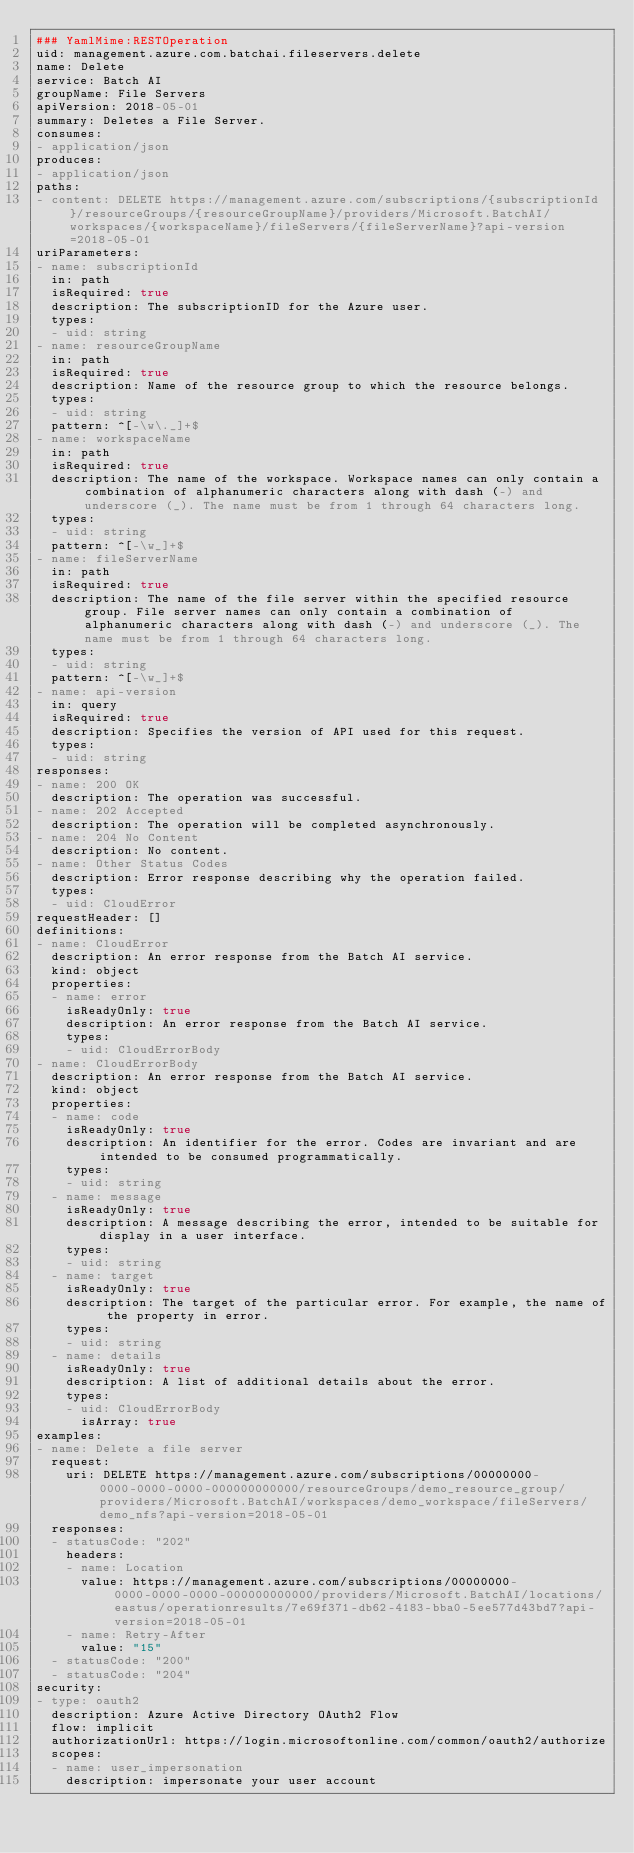<code> <loc_0><loc_0><loc_500><loc_500><_YAML_>### YamlMime:RESTOperation
uid: management.azure.com.batchai.fileservers.delete
name: Delete
service: Batch AI
groupName: File Servers
apiVersion: 2018-05-01
summary: Deletes a File Server.
consumes:
- application/json
produces:
- application/json
paths:
- content: DELETE https://management.azure.com/subscriptions/{subscriptionId}/resourceGroups/{resourceGroupName}/providers/Microsoft.BatchAI/workspaces/{workspaceName}/fileServers/{fileServerName}?api-version=2018-05-01
uriParameters:
- name: subscriptionId
  in: path
  isRequired: true
  description: The subscriptionID for the Azure user.
  types:
  - uid: string
- name: resourceGroupName
  in: path
  isRequired: true
  description: Name of the resource group to which the resource belongs.
  types:
  - uid: string
  pattern: ^[-\w\._]+$
- name: workspaceName
  in: path
  isRequired: true
  description: The name of the workspace. Workspace names can only contain a combination of alphanumeric characters along with dash (-) and underscore (_). The name must be from 1 through 64 characters long.
  types:
  - uid: string
  pattern: ^[-\w_]+$
- name: fileServerName
  in: path
  isRequired: true
  description: The name of the file server within the specified resource group. File server names can only contain a combination of alphanumeric characters along with dash (-) and underscore (_). The name must be from 1 through 64 characters long.
  types:
  - uid: string
  pattern: ^[-\w_]+$
- name: api-version
  in: query
  isRequired: true
  description: Specifies the version of API used for this request.
  types:
  - uid: string
responses:
- name: 200 OK
  description: The operation was successful.
- name: 202 Accepted
  description: The operation will be completed asynchronously.
- name: 204 No Content
  description: No content.
- name: Other Status Codes
  description: Error response describing why the operation failed.
  types:
  - uid: CloudError
requestHeader: []
definitions:
- name: CloudError
  description: An error response from the Batch AI service.
  kind: object
  properties:
  - name: error
    isReadyOnly: true
    description: An error response from the Batch AI service.
    types:
    - uid: CloudErrorBody
- name: CloudErrorBody
  description: An error response from the Batch AI service.
  kind: object
  properties:
  - name: code
    isReadyOnly: true
    description: An identifier for the error. Codes are invariant and are intended to be consumed programmatically.
    types:
    - uid: string
  - name: message
    isReadyOnly: true
    description: A message describing the error, intended to be suitable for display in a user interface.
    types:
    - uid: string
  - name: target
    isReadyOnly: true
    description: The target of the particular error. For example, the name of the property in error.
    types:
    - uid: string
  - name: details
    isReadyOnly: true
    description: A list of additional details about the error.
    types:
    - uid: CloudErrorBody
      isArray: true
examples:
- name: Delete a file server
  request:
    uri: DELETE https://management.azure.com/subscriptions/00000000-0000-0000-0000-000000000000/resourceGroups/demo_resource_group/providers/Microsoft.BatchAI/workspaces/demo_workspace/fileServers/demo_nfs?api-version=2018-05-01
  responses:
  - statusCode: "202"
    headers:
    - name: Location
      value: https://management.azure.com/subscriptions/00000000-0000-0000-0000-000000000000/providers/Microsoft.BatchAI/locations/eastus/operationresults/7e69f371-db62-4183-bba0-5ee577d43bd7?api-version=2018-05-01
    - name: Retry-After
      value: "15"
  - statusCode: "200"
  - statusCode: "204"
security:
- type: oauth2
  description: Azure Active Directory OAuth2 Flow
  flow: implicit
  authorizationUrl: https://login.microsoftonline.com/common/oauth2/authorize
  scopes:
  - name: user_impersonation
    description: impersonate your user account
</code> 